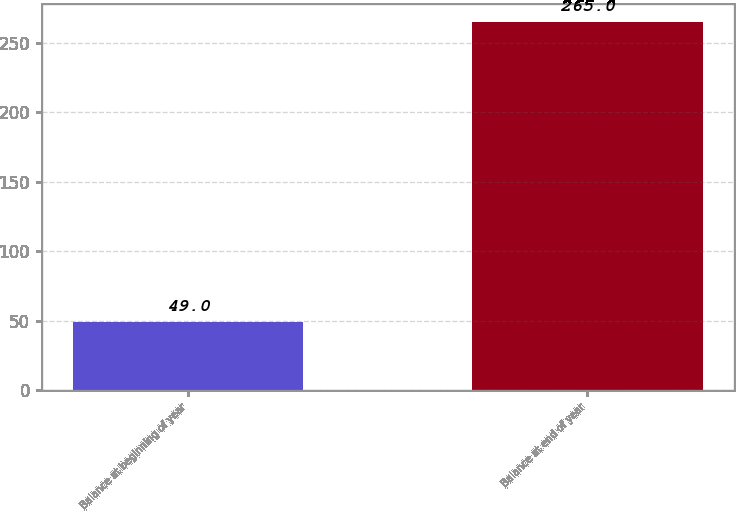<chart> <loc_0><loc_0><loc_500><loc_500><bar_chart><fcel>Balance at beginning of year<fcel>Balance at end of year<nl><fcel>49<fcel>265<nl></chart> 